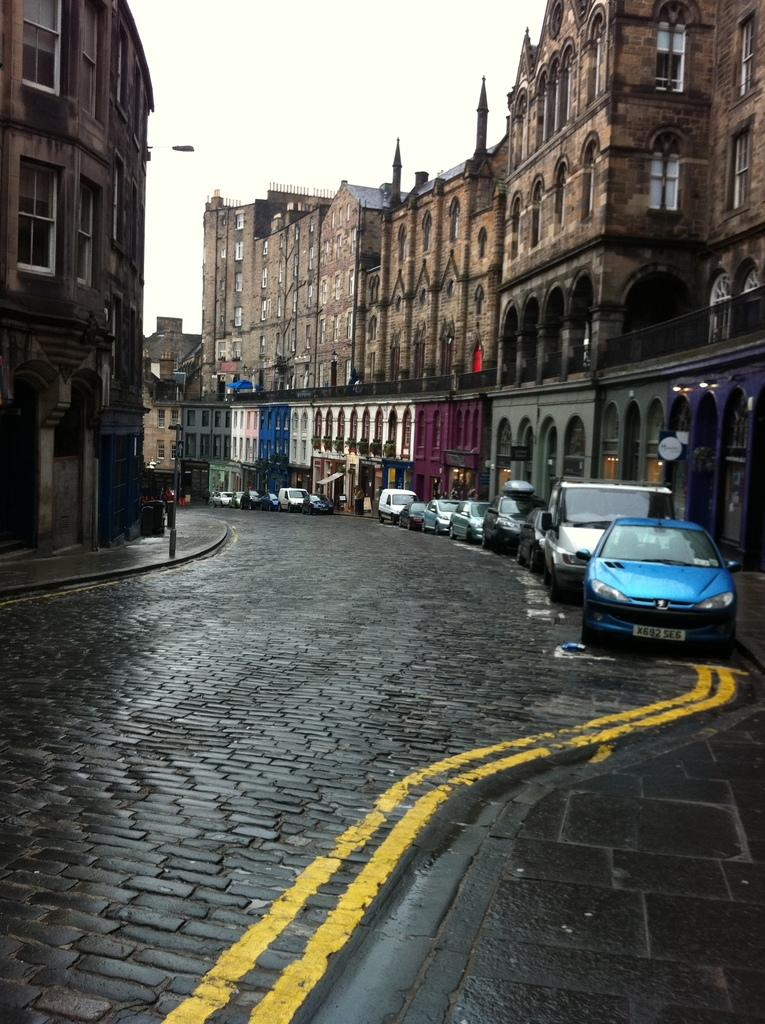<image>
Offer a succinct explanation of the picture presented. Many cars are parked in a market town street, the front vehicle has the plate X692 SE6 